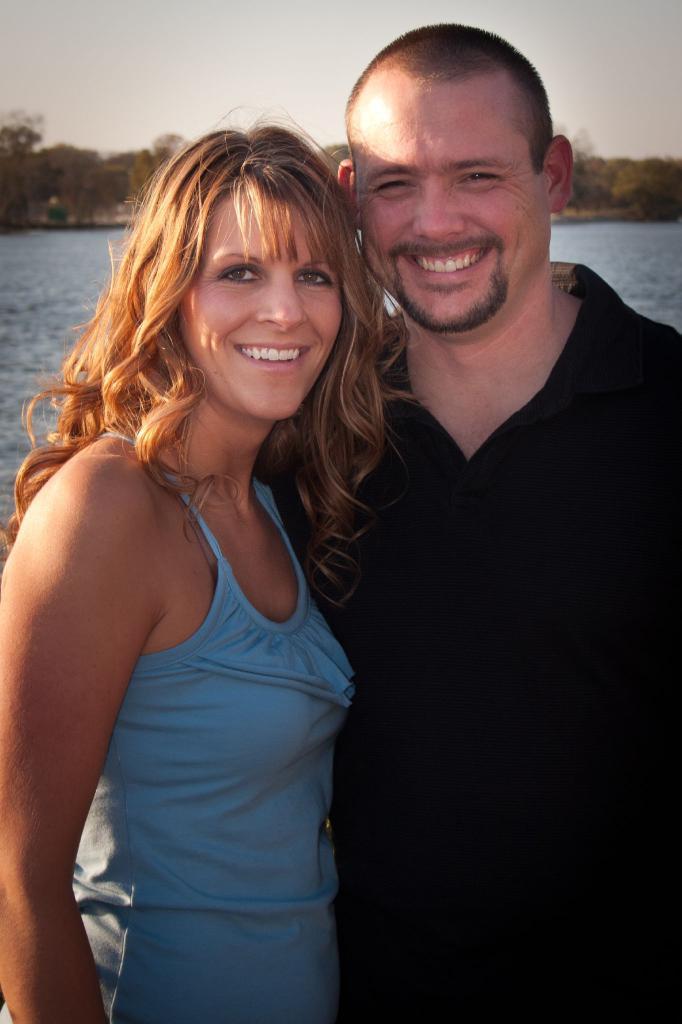Could you give a brief overview of what you see in this image? In this image we can see a woman wearing blue color dress and a man wearing black color dress are standing here and smiling. In the background, we can see the water, trees and the sky. 